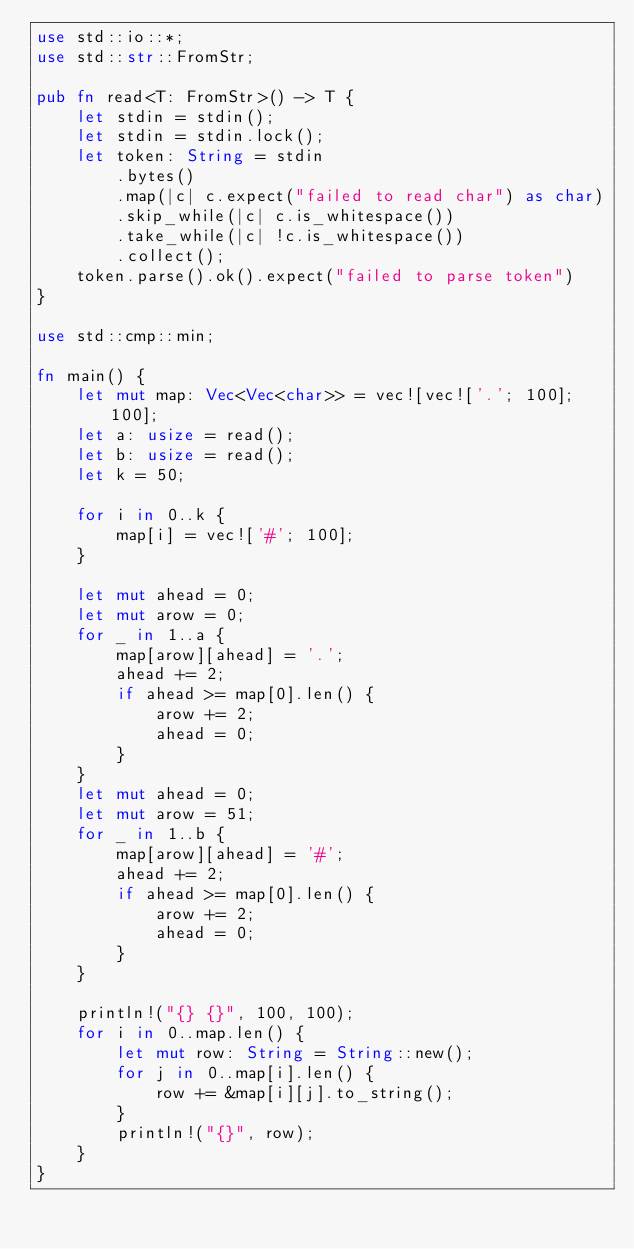<code> <loc_0><loc_0><loc_500><loc_500><_Rust_>use std::io::*;
use std::str::FromStr;

pub fn read<T: FromStr>() -> T {
    let stdin = stdin();
    let stdin = stdin.lock();
    let token: String = stdin
        .bytes()
        .map(|c| c.expect("failed to read char") as char)
        .skip_while(|c| c.is_whitespace())
        .take_while(|c| !c.is_whitespace())
        .collect();
    token.parse().ok().expect("failed to parse token")
}

use std::cmp::min;

fn main() {
    let mut map: Vec<Vec<char>> = vec![vec!['.'; 100]; 100];
    let a: usize = read();
    let b: usize = read();
    let k = 50;

    for i in 0..k {
        map[i] = vec!['#'; 100];
    }

    let mut ahead = 0;
    let mut arow = 0;
    for _ in 1..a {
        map[arow][ahead] = '.';
        ahead += 2;
        if ahead >= map[0].len() {
            arow += 2;
            ahead = 0;
        }
    }
    let mut ahead = 0;
    let mut arow = 51;
    for _ in 1..b {
        map[arow][ahead] = '#';
        ahead += 2;
        if ahead >= map[0].len() {
            arow += 2;
            ahead = 0;
        }
    }

    println!("{} {}", 100, 100);
    for i in 0..map.len() {
        let mut row: String = String::new();
        for j in 0..map[i].len() {
            row += &map[i][j].to_string();
        }
        println!("{}", row);
    }
}
</code> 